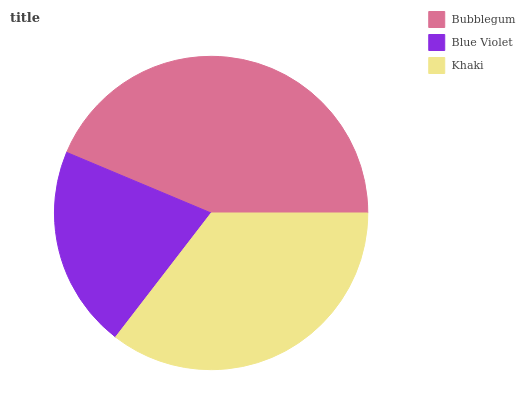Is Blue Violet the minimum?
Answer yes or no. Yes. Is Bubblegum the maximum?
Answer yes or no. Yes. Is Khaki the minimum?
Answer yes or no. No. Is Khaki the maximum?
Answer yes or no. No. Is Khaki greater than Blue Violet?
Answer yes or no. Yes. Is Blue Violet less than Khaki?
Answer yes or no. Yes. Is Blue Violet greater than Khaki?
Answer yes or no. No. Is Khaki less than Blue Violet?
Answer yes or no. No. Is Khaki the high median?
Answer yes or no. Yes. Is Khaki the low median?
Answer yes or no. Yes. Is Bubblegum the high median?
Answer yes or no. No. Is Blue Violet the low median?
Answer yes or no. No. 